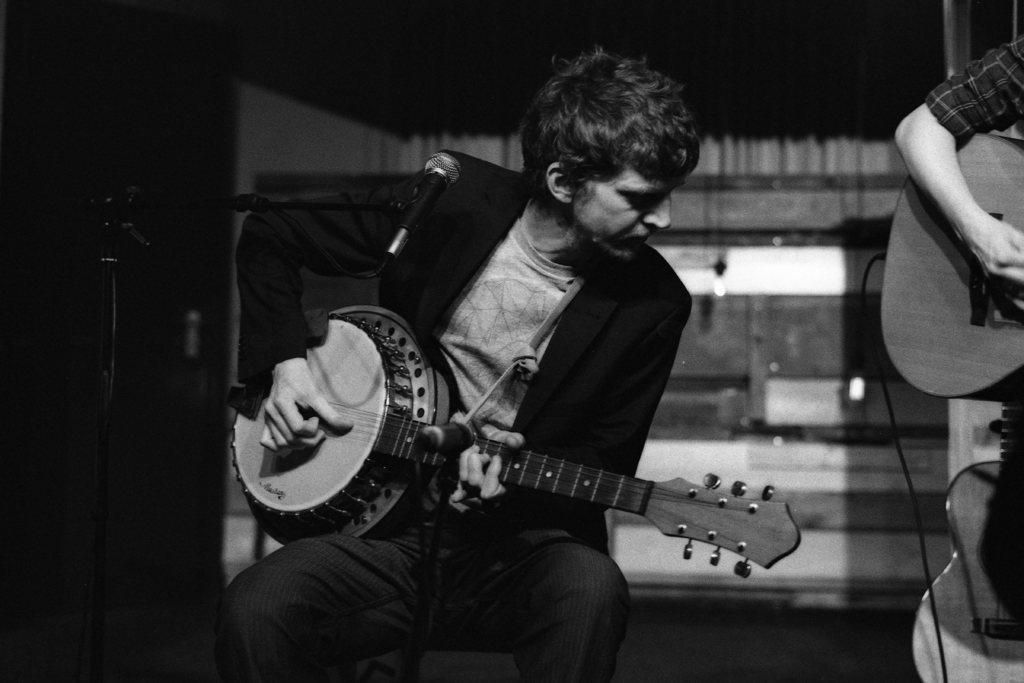In one or two sentences, can you explain what this image depicts? In this image i can see a person is sitting on the chair by holding a guitar and playing a guitar. Here i can see a microphone in front of the person and the person is wearing a black coat. 